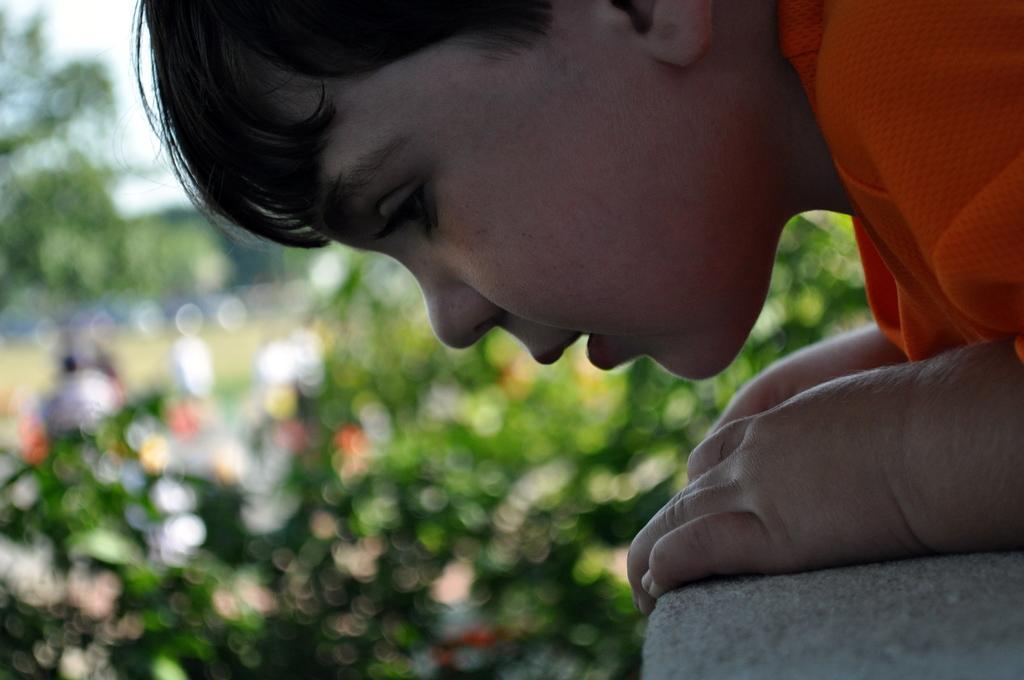Please provide a concise description of this image. In this image we can see a kid holding a wall and a blurry background. 